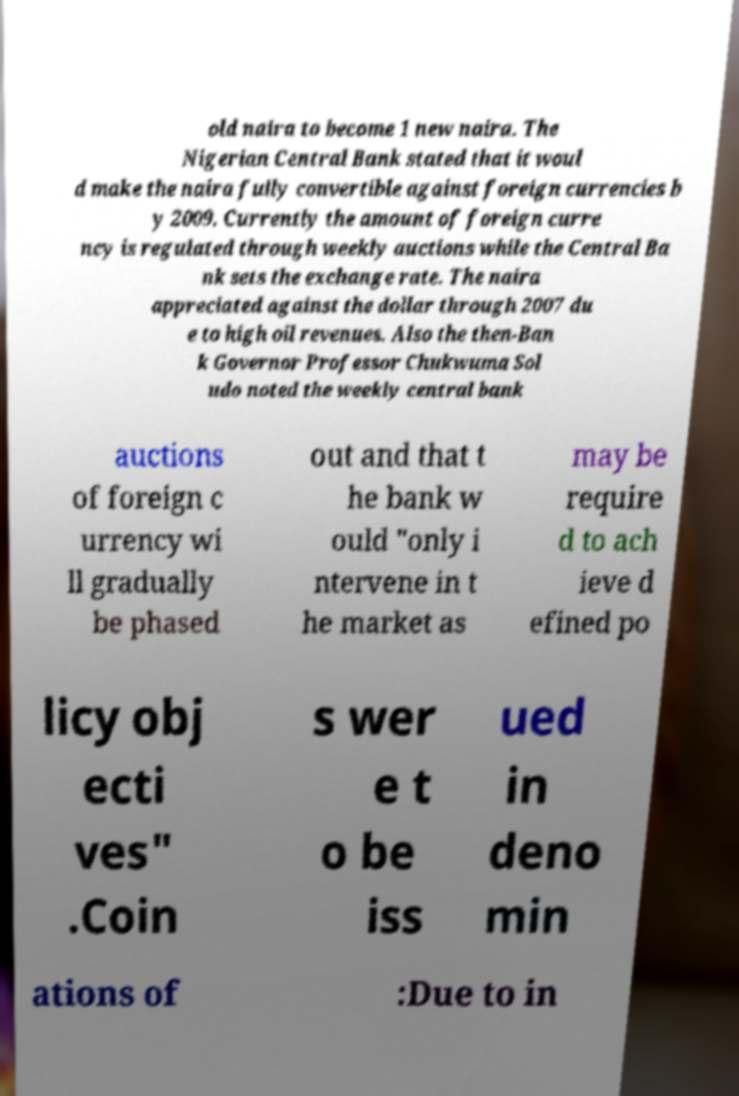Please read and relay the text visible in this image. What does it say? old naira to become 1 new naira. The Nigerian Central Bank stated that it woul d make the naira fully convertible against foreign currencies b y 2009. Currently the amount of foreign curre ncy is regulated through weekly auctions while the Central Ba nk sets the exchange rate. The naira appreciated against the dollar through 2007 du e to high oil revenues. Also the then-Ban k Governor Professor Chukwuma Sol udo noted the weekly central bank auctions of foreign c urrency wi ll gradually be phased out and that t he bank w ould "only i ntervene in t he market as may be require d to ach ieve d efined po licy obj ecti ves" .Coin s wer e t o be iss ued in deno min ations of :Due to in 